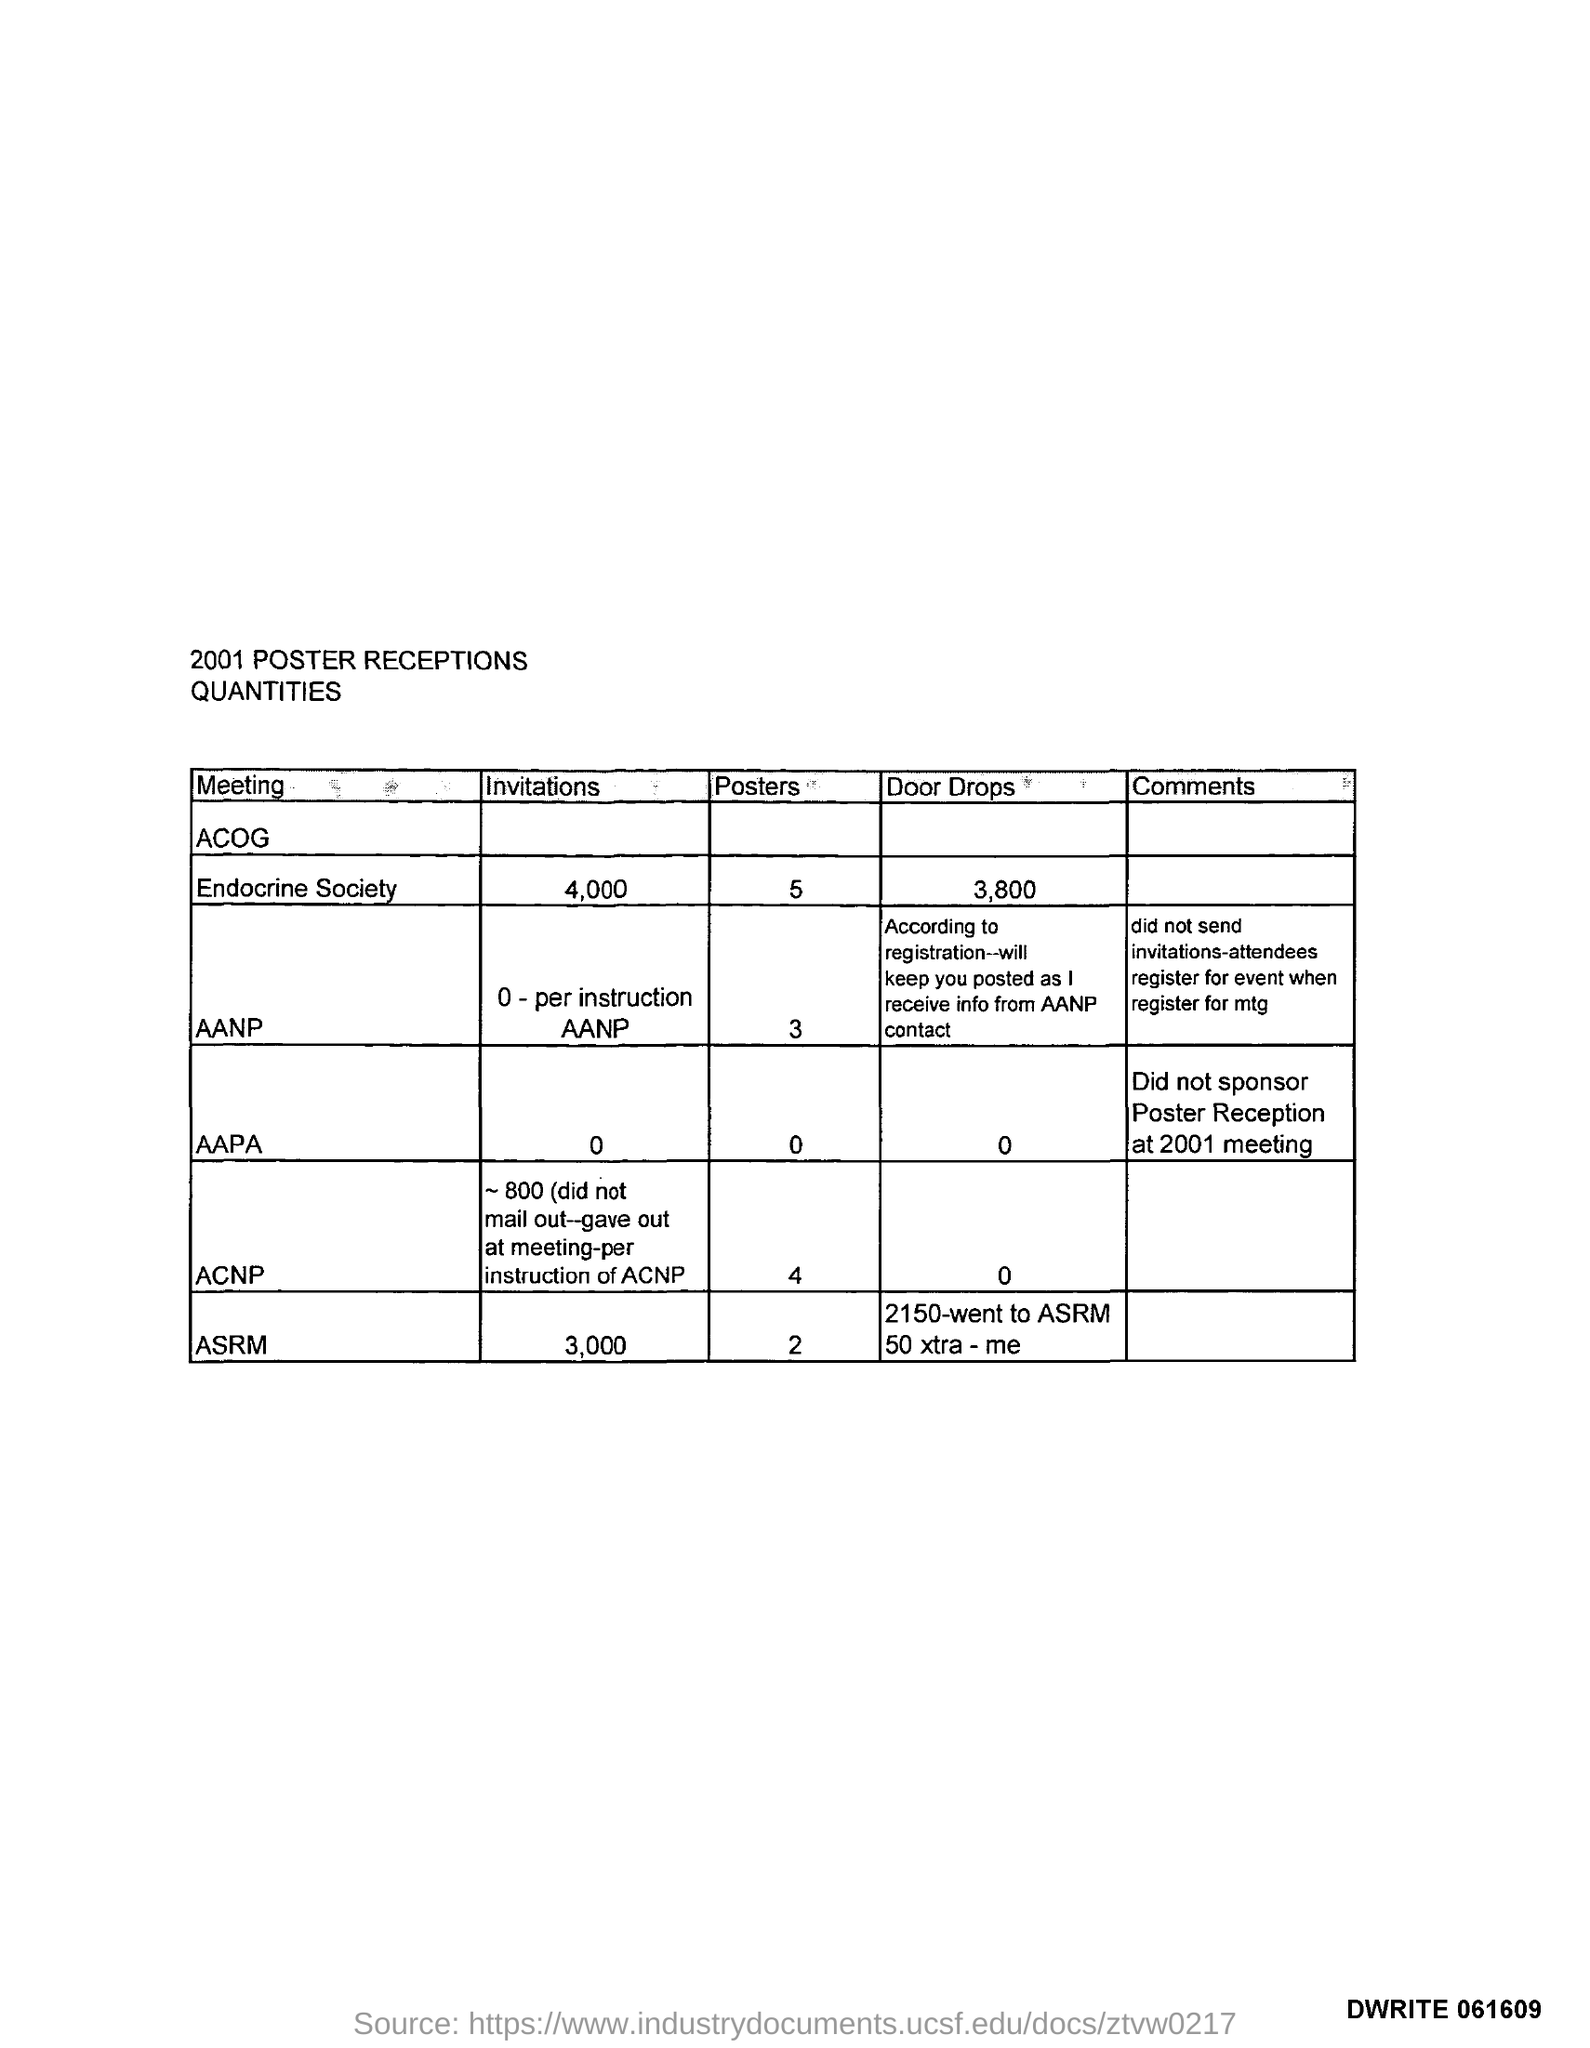What is the title of the given table?
Your answer should be very brief. 2001 poster receptions quantities. What is the code at the bottom right corner of the page?
Keep it short and to the point. Dwrite 061609. How many door drops for Endocrine Society?
Your answer should be compact. 3,800. How many invitations for AANP?
Your answer should be very brief. 0 - per instruction AANP. How many posters for ASRM?
Ensure brevity in your answer.  2. What are the comments for AAPA?
Make the answer very short. Did not sponsor poster reception at 2001 meeting. 